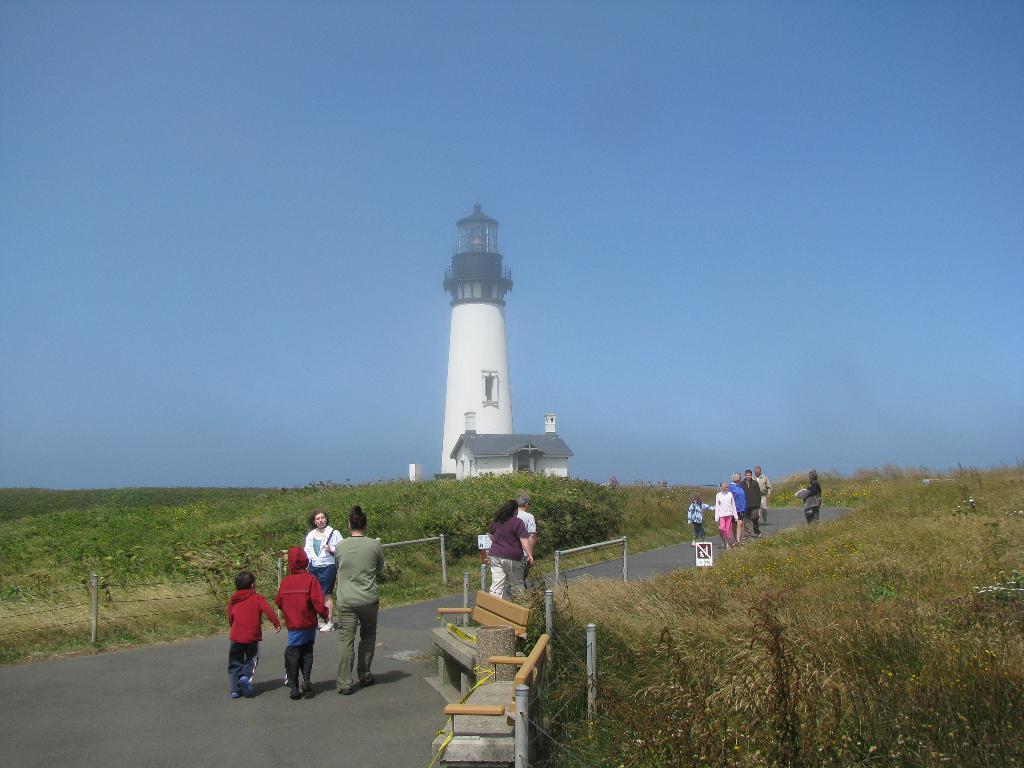Please provide a concise description of this image. In this image there is grass on the left and right corner. There are people, benches, there is a metal fence in the foreground. There is a road at the bottom. It looks like a tower in the background. And there is sky at the top. 